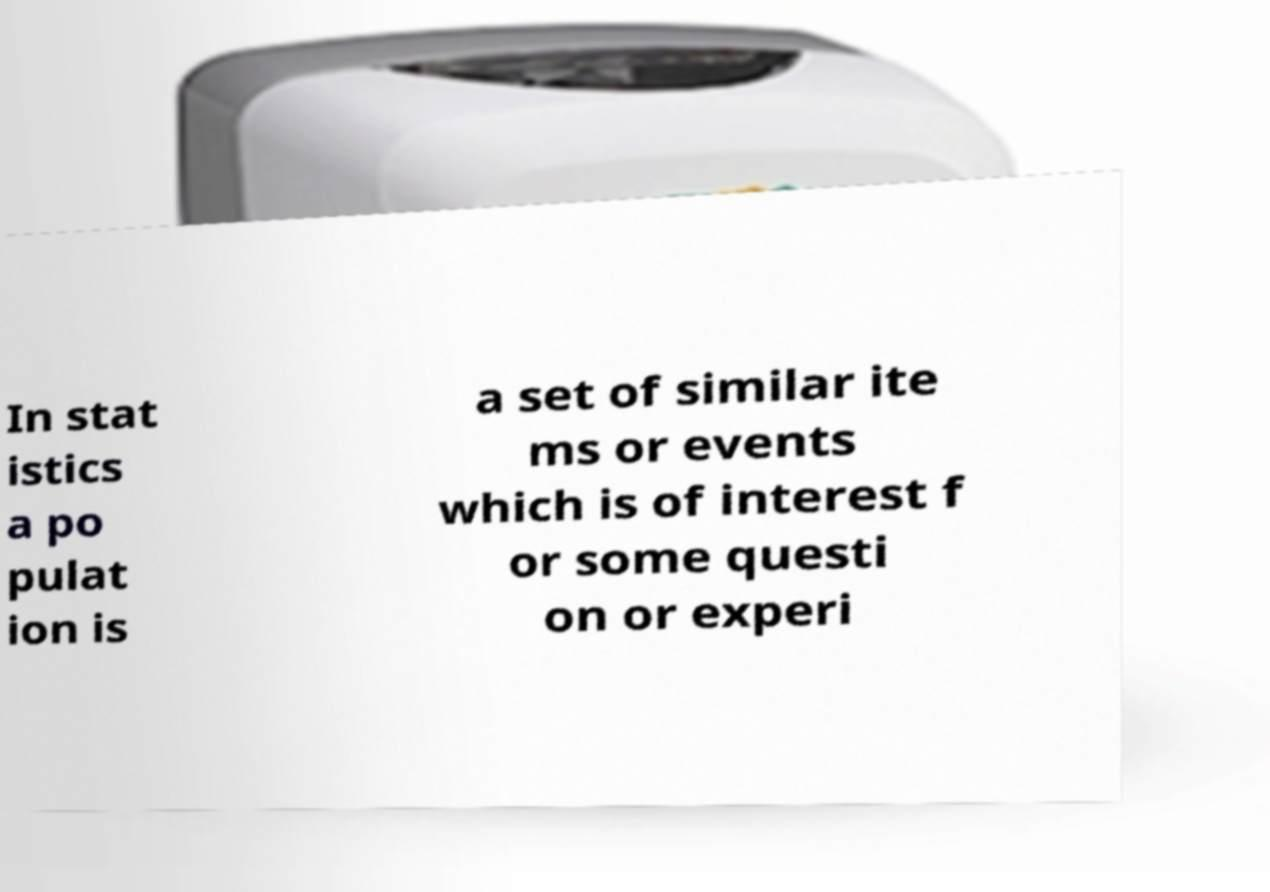I need the written content from this picture converted into text. Can you do that? In stat istics a po pulat ion is a set of similar ite ms or events which is of interest f or some questi on or experi 